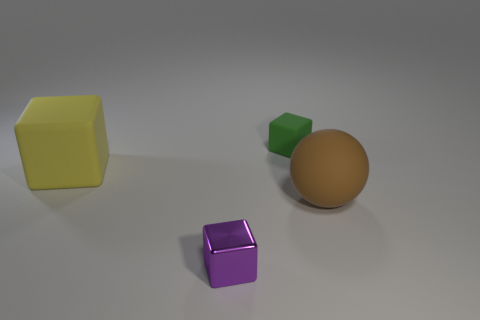Subtract all shiny cubes. How many cubes are left? 2 Add 4 metallic spheres. How many objects exist? 8 Subtract all cyan cubes. Subtract all blue balls. How many cubes are left? 3 Subtract all cubes. How many objects are left? 1 Subtract 0 gray spheres. How many objects are left? 4 Subtract all big red rubber things. Subtract all matte balls. How many objects are left? 3 Add 3 yellow blocks. How many yellow blocks are left? 4 Add 1 big purple metal cubes. How many big purple metal cubes exist? 1 